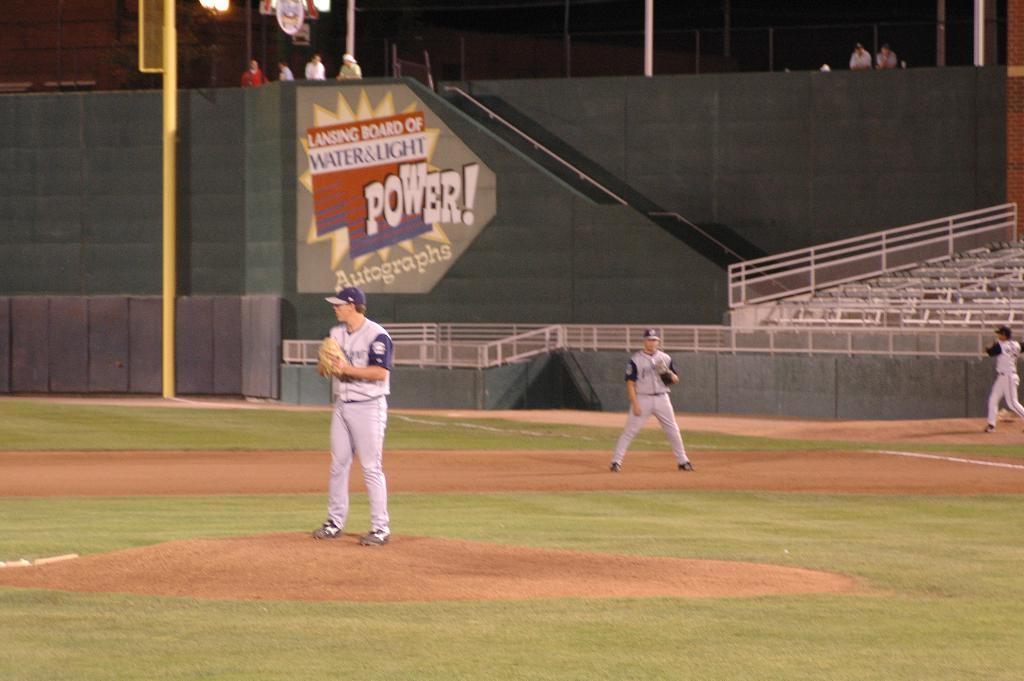<image>
Summarize the visual content of the image. A baseball game being played under a sign that says 'Lansing Board of Water & Light'. 